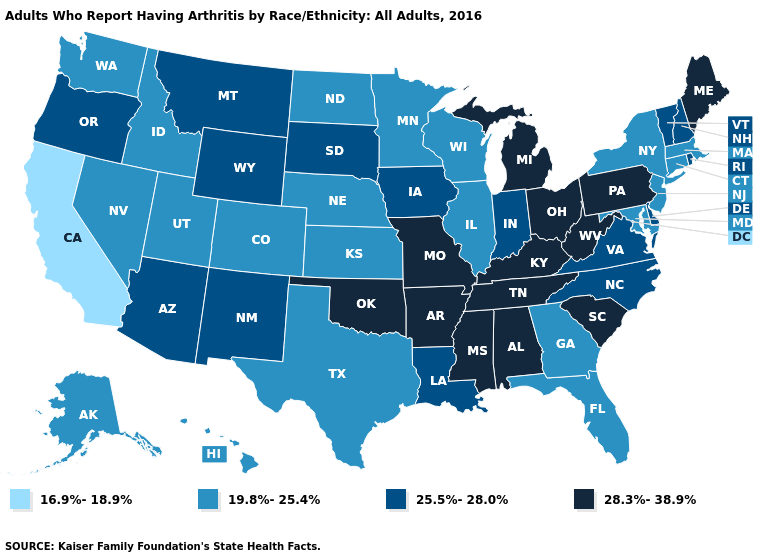What is the value of Kentucky?
Concise answer only. 28.3%-38.9%. Name the states that have a value in the range 25.5%-28.0%?
Answer briefly. Arizona, Delaware, Indiana, Iowa, Louisiana, Montana, New Hampshire, New Mexico, North Carolina, Oregon, Rhode Island, South Dakota, Vermont, Virginia, Wyoming. Does the first symbol in the legend represent the smallest category?
Short answer required. Yes. Is the legend a continuous bar?
Keep it brief. No. Does Kansas have the highest value in the MidWest?
Write a very short answer. No. Name the states that have a value in the range 16.9%-18.9%?
Give a very brief answer. California. Does Illinois have the lowest value in the MidWest?
Give a very brief answer. Yes. What is the lowest value in the South?
Write a very short answer. 19.8%-25.4%. Name the states that have a value in the range 28.3%-38.9%?
Short answer required. Alabama, Arkansas, Kentucky, Maine, Michigan, Mississippi, Missouri, Ohio, Oklahoma, Pennsylvania, South Carolina, Tennessee, West Virginia. Among the states that border New Jersey , which have the highest value?
Give a very brief answer. Pennsylvania. What is the value of Kentucky?
Short answer required. 28.3%-38.9%. What is the value of Rhode Island?
Answer briefly. 25.5%-28.0%. Name the states that have a value in the range 25.5%-28.0%?
Keep it brief. Arizona, Delaware, Indiana, Iowa, Louisiana, Montana, New Hampshire, New Mexico, North Carolina, Oregon, Rhode Island, South Dakota, Vermont, Virginia, Wyoming. Is the legend a continuous bar?
Write a very short answer. No. What is the highest value in the USA?
Keep it brief. 28.3%-38.9%. 